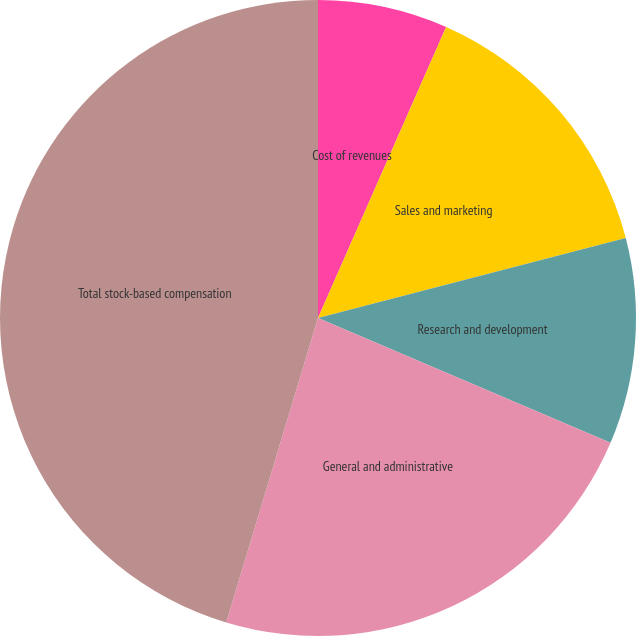<chart> <loc_0><loc_0><loc_500><loc_500><pie_chart><fcel>Cost of revenues<fcel>Sales and marketing<fcel>Research and development<fcel>General and administrative<fcel>Total stock-based compensation<nl><fcel>6.6%<fcel>14.35%<fcel>10.47%<fcel>23.24%<fcel>45.34%<nl></chart> 